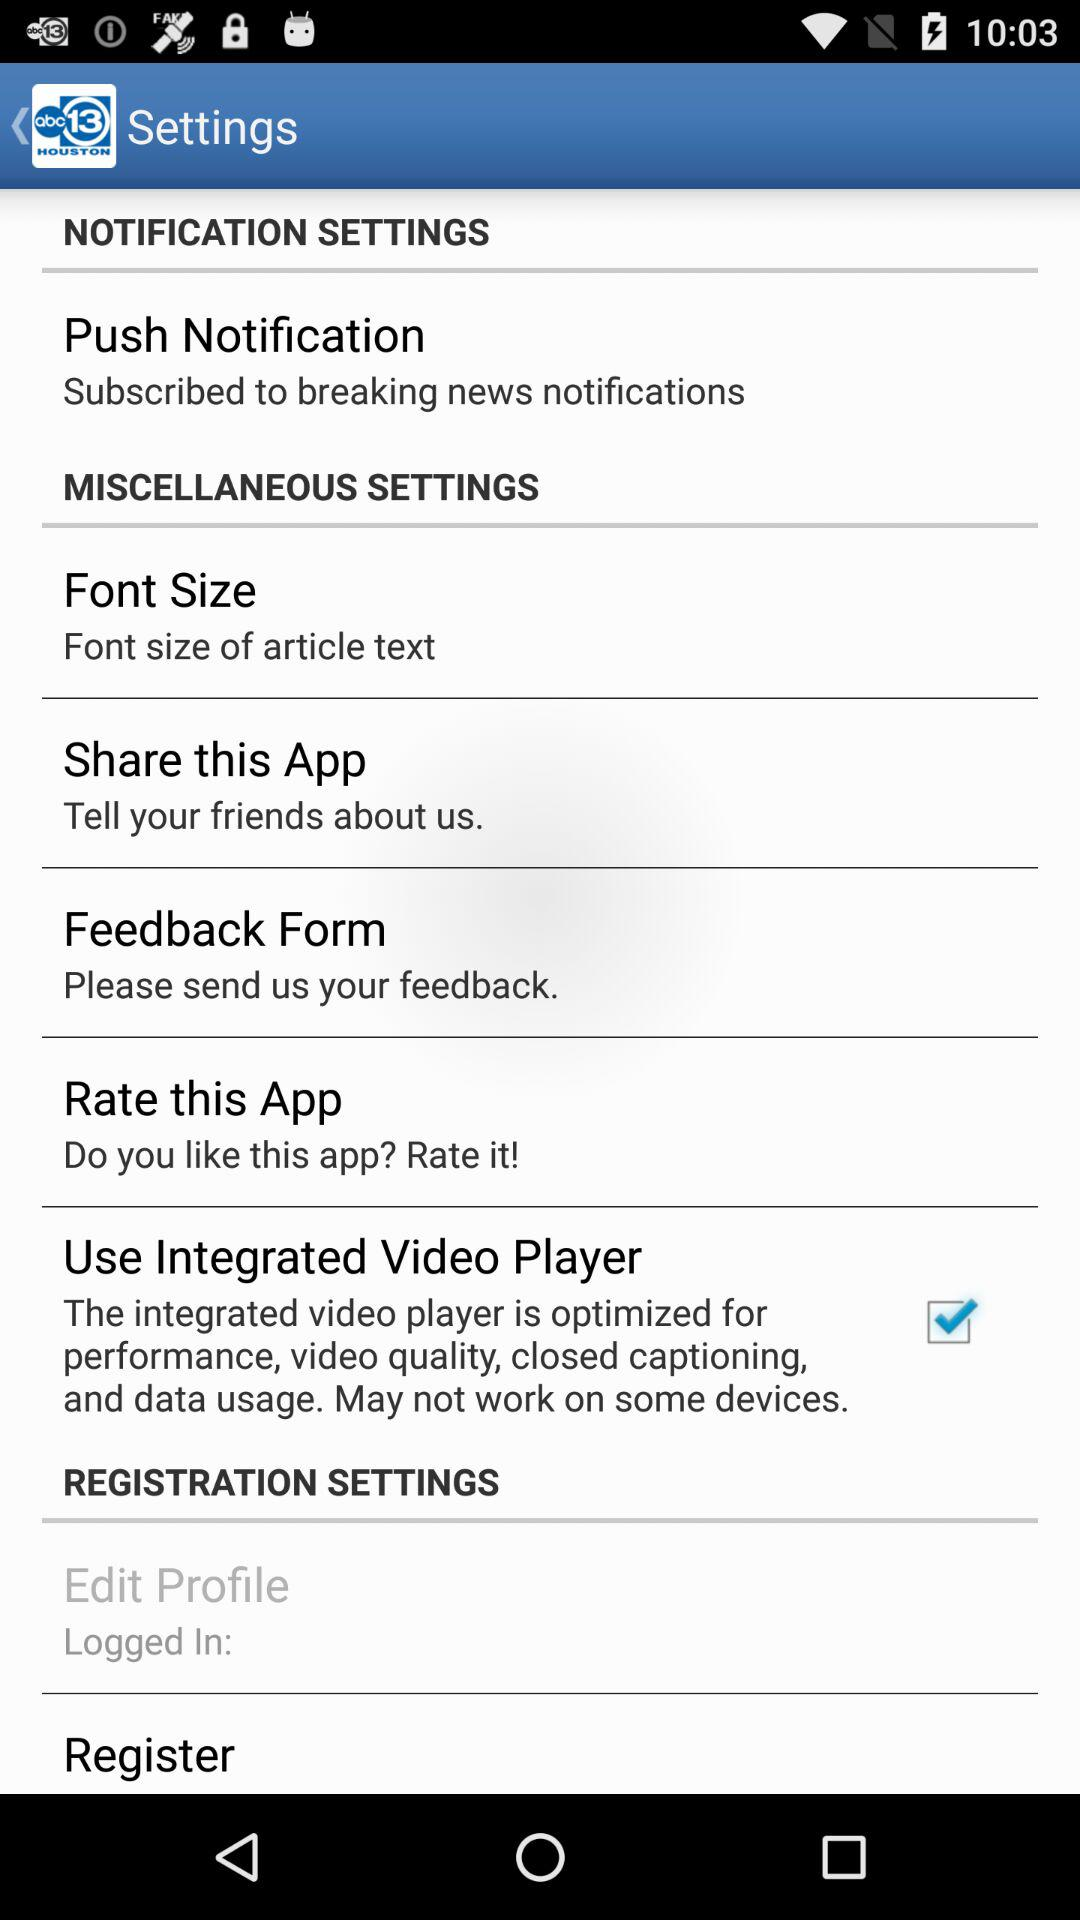How many items are in the registration settings section?
Answer the question using a single word or phrase. 2 